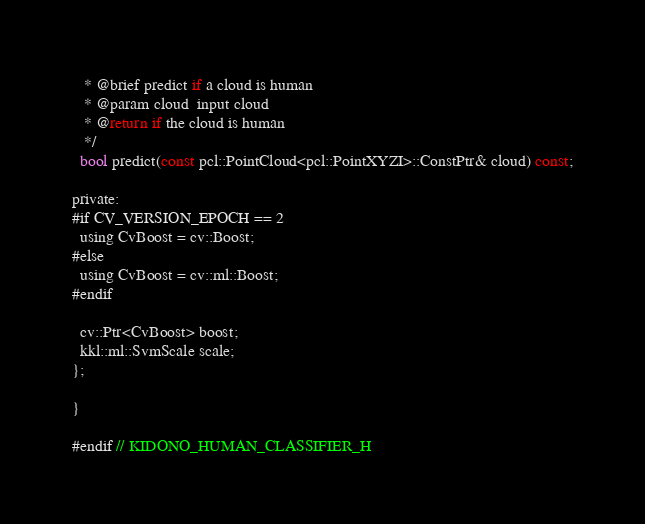<code> <loc_0><loc_0><loc_500><loc_500><_C_>   * @brief predict if a cloud is human
   * @param cloud  input cloud
   * @return if the cloud is human
   */
  bool predict(const pcl::PointCloud<pcl::PointXYZI>::ConstPtr& cloud) const;

private:
#if CV_VERSION_EPOCH == 2
  using CvBoost = cv::Boost;
#else
  using CvBoost = cv::ml::Boost;
#endif

  cv::Ptr<CvBoost> boost;
  kkl::ml::SvmScale scale;
};

}

#endif // KIDONO_HUMAN_CLASSIFIER_H
</code> 